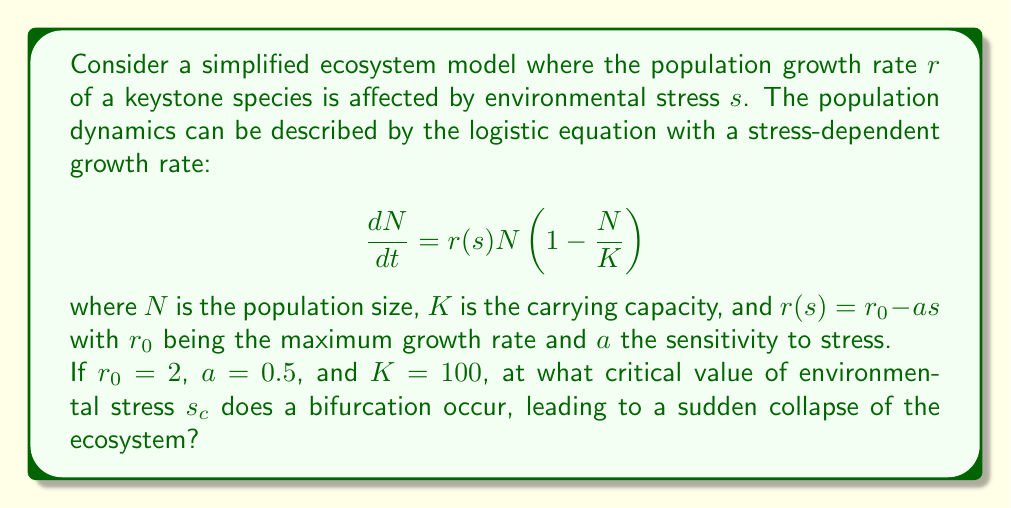Teach me how to tackle this problem. To solve this problem, we need to follow these steps:

1) In the logistic equation, a bifurcation occurs when the growth rate $r(s)$ becomes negative. At this point, the population will decrease regardless of its current size, leading to extinction.

2) We can find the critical stress $s_c$ by setting $r(s) = 0$:

   $$r(s) = r_0 - as = 0$$

3) Substituting the given values:

   $$2 - 0.5s = 0$$

4) Solving for $s$:

   $$0.5s = 2$$
   $$s = \frac{2}{0.5} = 4$$

5) Therefore, the critical stress $s_c$ is 4.

6) We can verify this by looking at the behavior of the system:
   - For $s < 4$, $r(s) > 0$, and the population has a stable non-zero equilibrium.
   - For $s = 4$, $r(s) = 0$, which is the bifurcation point.
   - For $s > 4$, $r(s) < 0$, and the population will go extinct.

This bifurcation represents a tipping point in the ecosystem stability. Beyond this point, the keystone species cannot maintain a viable population, potentially leading to a cascade of extinctions and ecosystem collapse.
Answer: $s_c = 4$ 